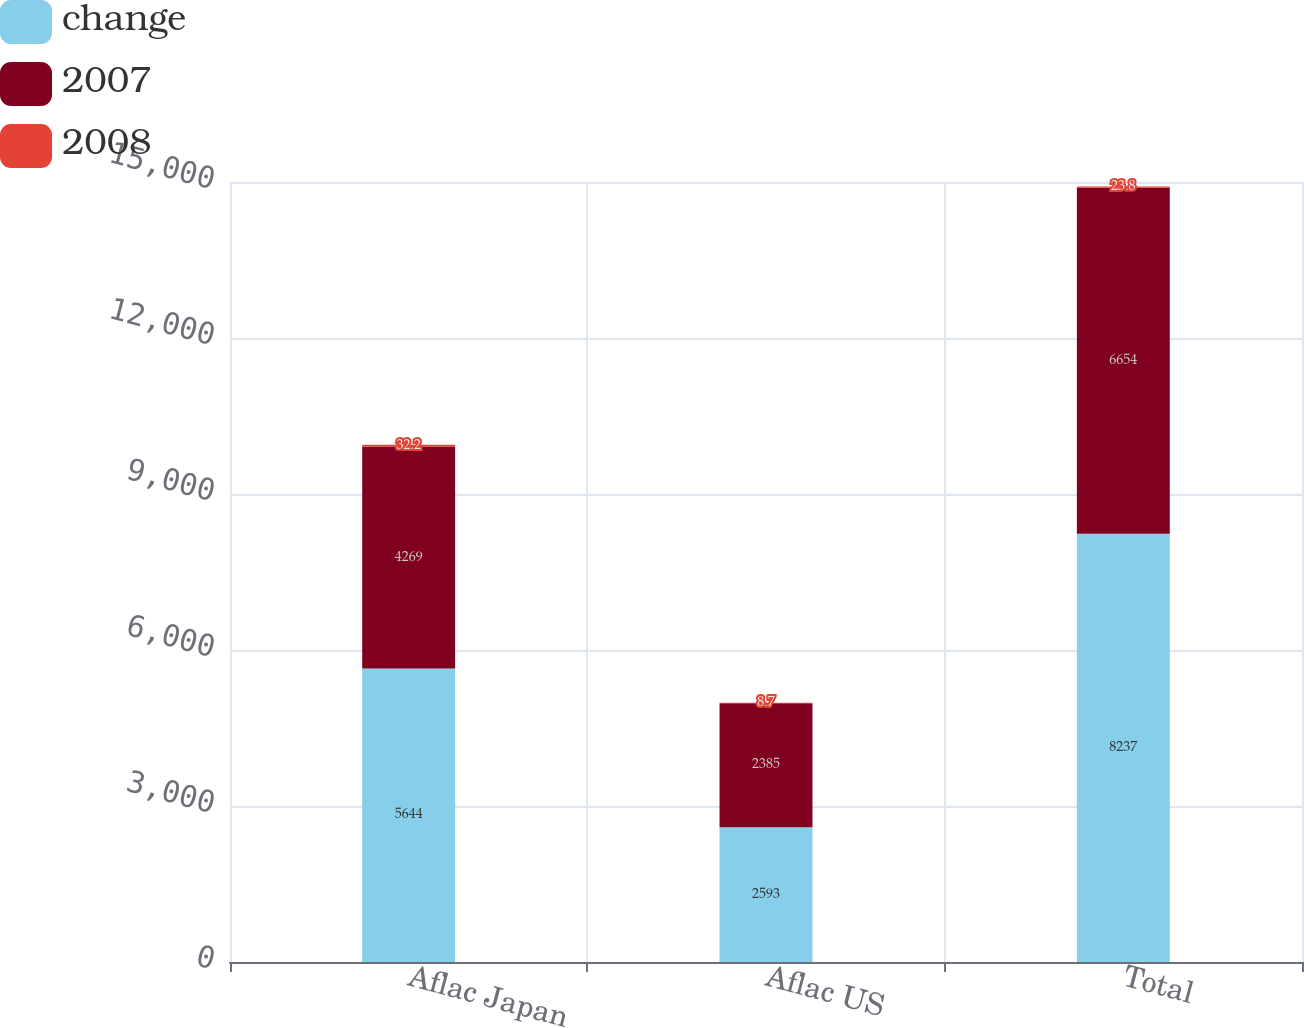Convert chart. <chart><loc_0><loc_0><loc_500><loc_500><stacked_bar_chart><ecel><fcel>Aflac Japan<fcel>Aflac US<fcel>Total<nl><fcel>change<fcel>5644<fcel>2593<fcel>8237<nl><fcel>2007<fcel>4269<fcel>2385<fcel>6654<nl><fcel>2008<fcel>32.2<fcel>8.7<fcel>23.8<nl></chart> 